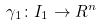<formula> <loc_0><loc_0><loc_500><loc_500>\gamma _ { 1 } \colon I _ { 1 } \rightarrow R ^ { n }</formula> 